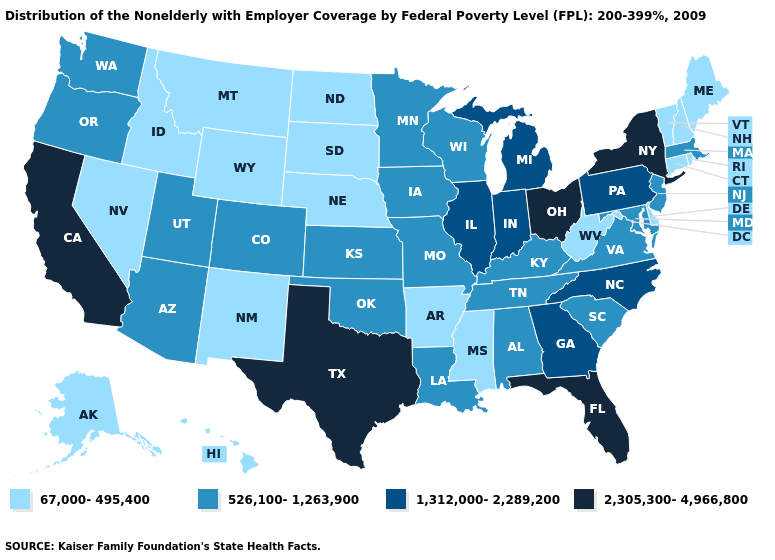What is the lowest value in states that border Oklahoma?
Short answer required. 67,000-495,400. Which states have the highest value in the USA?
Keep it brief. California, Florida, New York, Ohio, Texas. What is the lowest value in the South?
Answer briefly. 67,000-495,400. Does Texas have the lowest value in the South?
Give a very brief answer. No. What is the lowest value in states that border Montana?
Short answer required. 67,000-495,400. Does Wyoming have the highest value in the USA?
Short answer required. No. What is the value of Iowa?
Quick response, please. 526,100-1,263,900. Among the states that border Texas , does New Mexico have the highest value?
Concise answer only. No. What is the value of Mississippi?
Quick response, please. 67,000-495,400. Name the states that have a value in the range 1,312,000-2,289,200?
Give a very brief answer. Georgia, Illinois, Indiana, Michigan, North Carolina, Pennsylvania. Name the states that have a value in the range 67,000-495,400?
Answer briefly. Alaska, Arkansas, Connecticut, Delaware, Hawaii, Idaho, Maine, Mississippi, Montana, Nebraska, Nevada, New Hampshire, New Mexico, North Dakota, Rhode Island, South Dakota, Vermont, West Virginia, Wyoming. What is the lowest value in states that border South Dakota?
Short answer required. 67,000-495,400. Which states have the lowest value in the MidWest?
Be succinct. Nebraska, North Dakota, South Dakota. Does Maine have the lowest value in the USA?
Answer briefly. Yes. Does Tennessee have the same value as New York?
Write a very short answer. No. 